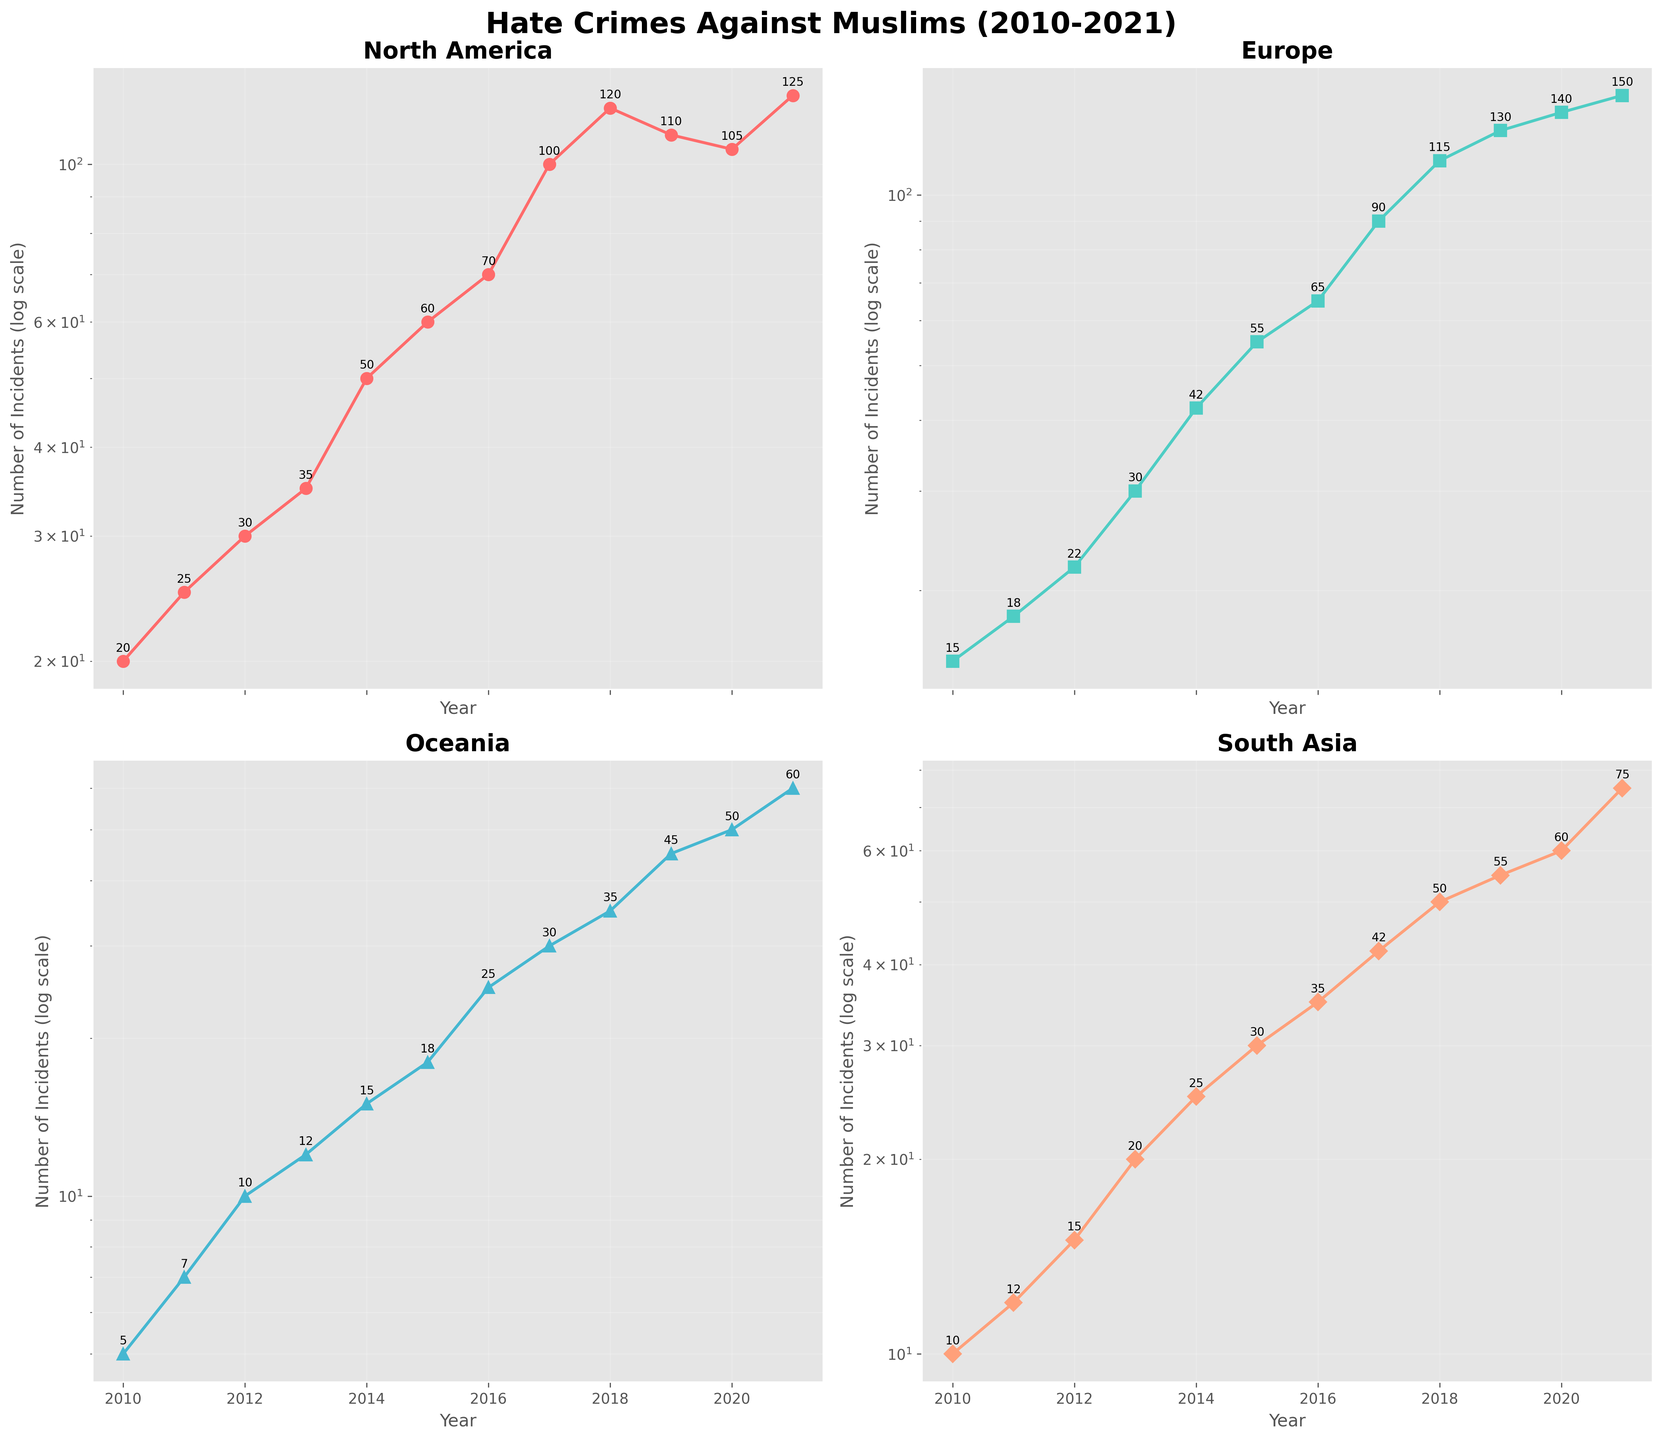What is the title of the figure? The title is located at the top of the figure. It reads "Hate Crimes Against Muslims (2010-2021)."
Answer: Hate Crimes Against Muslims (2010-2021) How many regions are plotted in the figure? The figure consists of four subplots, each representing a different region. The regions listed are North America, Europe, Oceania, and South Asia.
Answer: 4 Which region has the highest number of incidents in 2021? Each subplot has an annotation for the number of incidents in 2021. By comparing the numbers, Europe has the highest number of incidents with 150 incidents.
Answer: Europe What trend do you observe in North America from 2010 to 2021? The line plot in the North America subplot shows a general upward trend over the years. The number of incidents gradually increases from 20 in 2010 to 125 in 2021, with some fluctuations.
Answer: Increasing trend Which year saw the largest number of incidents in South Asia? By looking at the data points and annotations in the South Asia subplot, the year 2021 has the highest number of incidents with 75 incidents.
Answer: 2021 Are there any years where Europe had fewer incidents than North America? If so, which years? By comparing the two subplots for Europe and North America, Europe had fewer incidents than North America in the years from 2010 to 2015.
Answer: 2010 to 2015 How does the number of incidents in Oceania in 2016 compare to the number in 2015? By looking at the subplot for Oceania, the number of incidents in 2016 is 25, whereas in 2015 it is 18. This shows an increase in incidents from 2015 to 2016.
Answer: Increase Which region had the lowest number of incidents in 2010? By examining the annotations in each subplot for the year 2010, Oceania had the lowest number of incidents with only 5.
Answer: Oceania Which region shows the most consistent upward trend in incidents over the decade? By comparing the slopes of the line plots across all subplots, the line in Europe consistently goes upward without significant drops, indicating a continuous and consistent increase.
Answer: Europe 